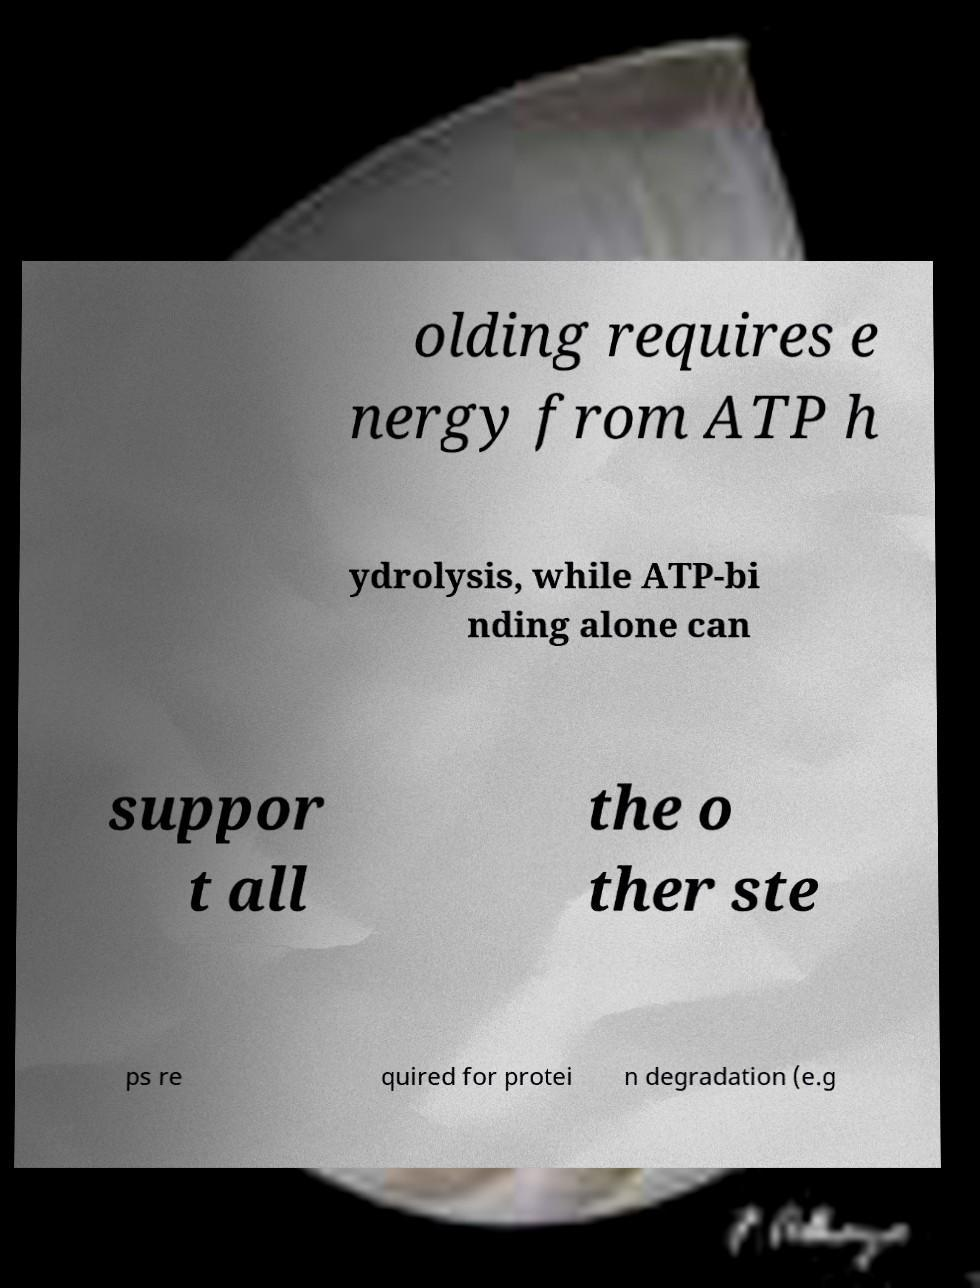Can you accurately transcribe the text from the provided image for me? olding requires e nergy from ATP h ydrolysis, while ATP-bi nding alone can suppor t all the o ther ste ps re quired for protei n degradation (e.g 